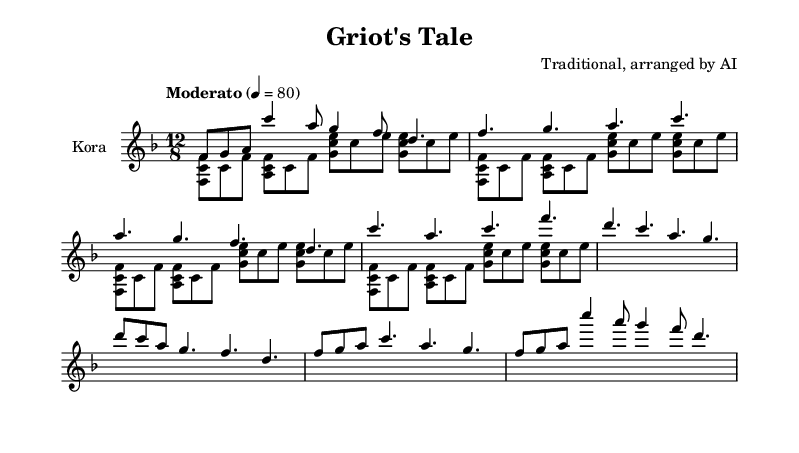What is the key signature of this music? The key signature is F major, which has one flat (B flat). This is indicated by the presence of a flat sign on the B line in the treble staff.
Answer: F major What is the time signature of the piece? The time signature is 12/8, which means there are 12 eighth notes in each measure. This is seen at the start of the score, where the time signature is explicitly written.
Answer: 12/8 What is the tempo marking for the music? The tempo marking is "Moderato," with a metronome indication of 80 beats per minute, suggesting a moderate speed for the performance. This information is located at the beginning of the score.
Answer: Moderato How many sections are there in the piece? There are five sections: Introduction, Verse 1, Chorus, Bridge, and Outro. Each section is marked explicitly in the music, showing the overall structure of the composition.
Answer: Five What is the starting note of the kora melody? The starting note of the kora melody is F. This can be identified as the first pitch in the printed music, which corresponds to the first note of the kora part.
Answer: F What type of music is this piece classified under? This piece is classified as traditional West African kora music. This classification can be derived from the instrumentation and the cultural context suggested by the music's structure, as well as the role of the kora in storytelling traditions.
Answer: Traditional West African kora music What is the overall dynamic marking for the melody? The overall dynamic marking for the melody is not explicitly indicated in the provided data, but typically in kora music, it is performed at a moderate dynamic level, which corresponds to the tempo marking.
Answer: Moderate 